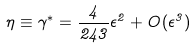Convert formula to latex. <formula><loc_0><loc_0><loc_500><loc_500>\eta \equiv \gamma ^ { * } = \frac { 4 } { 2 4 3 } \epsilon ^ { 2 } + O ( \epsilon ^ { 3 } )</formula> 